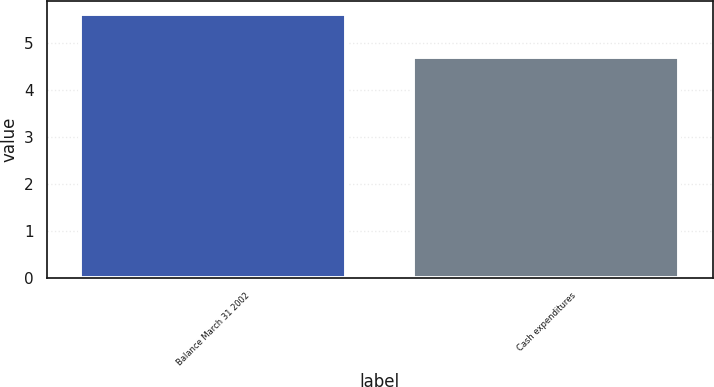Convert chart to OTSL. <chart><loc_0><loc_0><loc_500><loc_500><bar_chart><fcel>Balance March 31 2002<fcel>Cash expenditures<nl><fcel>5.6<fcel>4.7<nl></chart> 